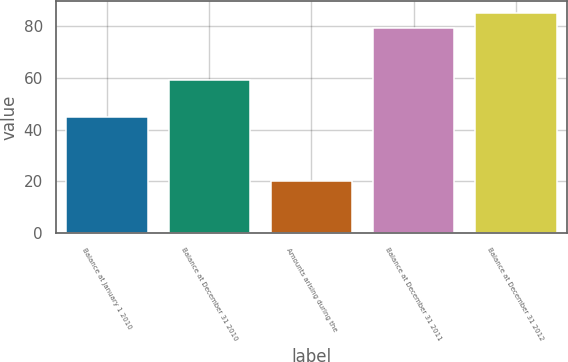Convert chart to OTSL. <chart><loc_0><loc_0><loc_500><loc_500><bar_chart><fcel>Balance at January 1 2010<fcel>Balance at December 31 2010<fcel>Amounts arising during the<fcel>Balance at December 31 2011<fcel>Balance at December 31 2012<nl><fcel>45<fcel>59<fcel>20<fcel>79<fcel>85<nl></chart> 